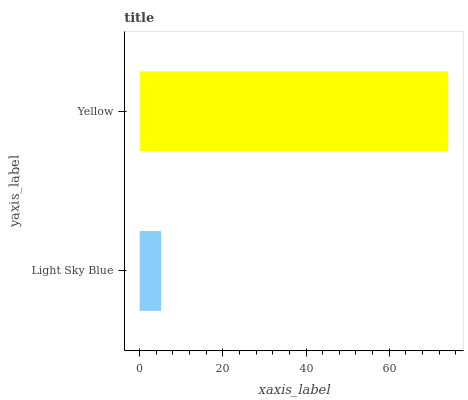Is Light Sky Blue the minimum?
Answer yes or no. Yes. Is Yellow the maximum?
Answer yes or no. Yes. Is Yellow the minimum?
Answer yes or no. No. Is Yellow greater than Light Sky Blue?
Answer yes or no. Yes. Is Light Sky Blue less than Yellow?
Answer yes or no. Yes. Is Light Sky Blue greater than Yellow?
Answer yes or no. No. Is Yellow less than Light Sky Blue?
Answer yes or no. No. Is Yellow the high median?
Answer yes or no. Yes. Is Light Sky Blue the low median?
Answer yes or no. Yes. Is Light Sky Blue the high median?
Answer yes or no. No. Is Yellow the low median?
Answer yes or no. No. 